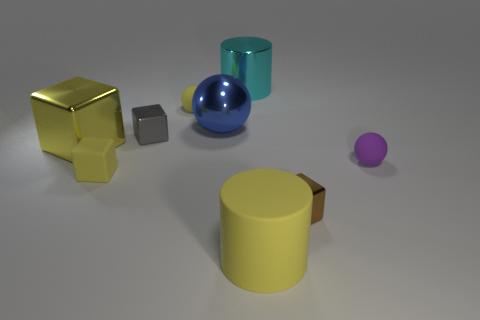Are there any other objects that have the same shape as the blue metal object?
Keep it short and to the point. Yes. There is a purple object that is the same size as the gray metallic block; what is it made of?
Your response must be concise. Rubber. What size is the yellow thing that is behind the gray cube?
Give a very brief answer. Small. There is a shiny thing right of the cyan cylinder; does it have the same size as the cylinder in front of the purple rubber sphere?
Make the answer very short. No. What number of balls are the same material as the large yellow cylinder?
Your answer should be very brief. 2. The rubber cube is what color?
Ensure brevity in your answer.  Yellow. Are there any large cyan cylinders in front of the cyan object?
Keep it short and to the point. No. Does the big metallic cube have the same color as the rubber cube?
Your answer should be very brief. Yes. What number of metal blocks are the same color as the large rubber cylinder?
Provide a succinct answer. 1. There is a cylinder that is behind the yellow cube that is behind the tiny yellow cube; how big is it?
Provide a short and direct response. Large. 